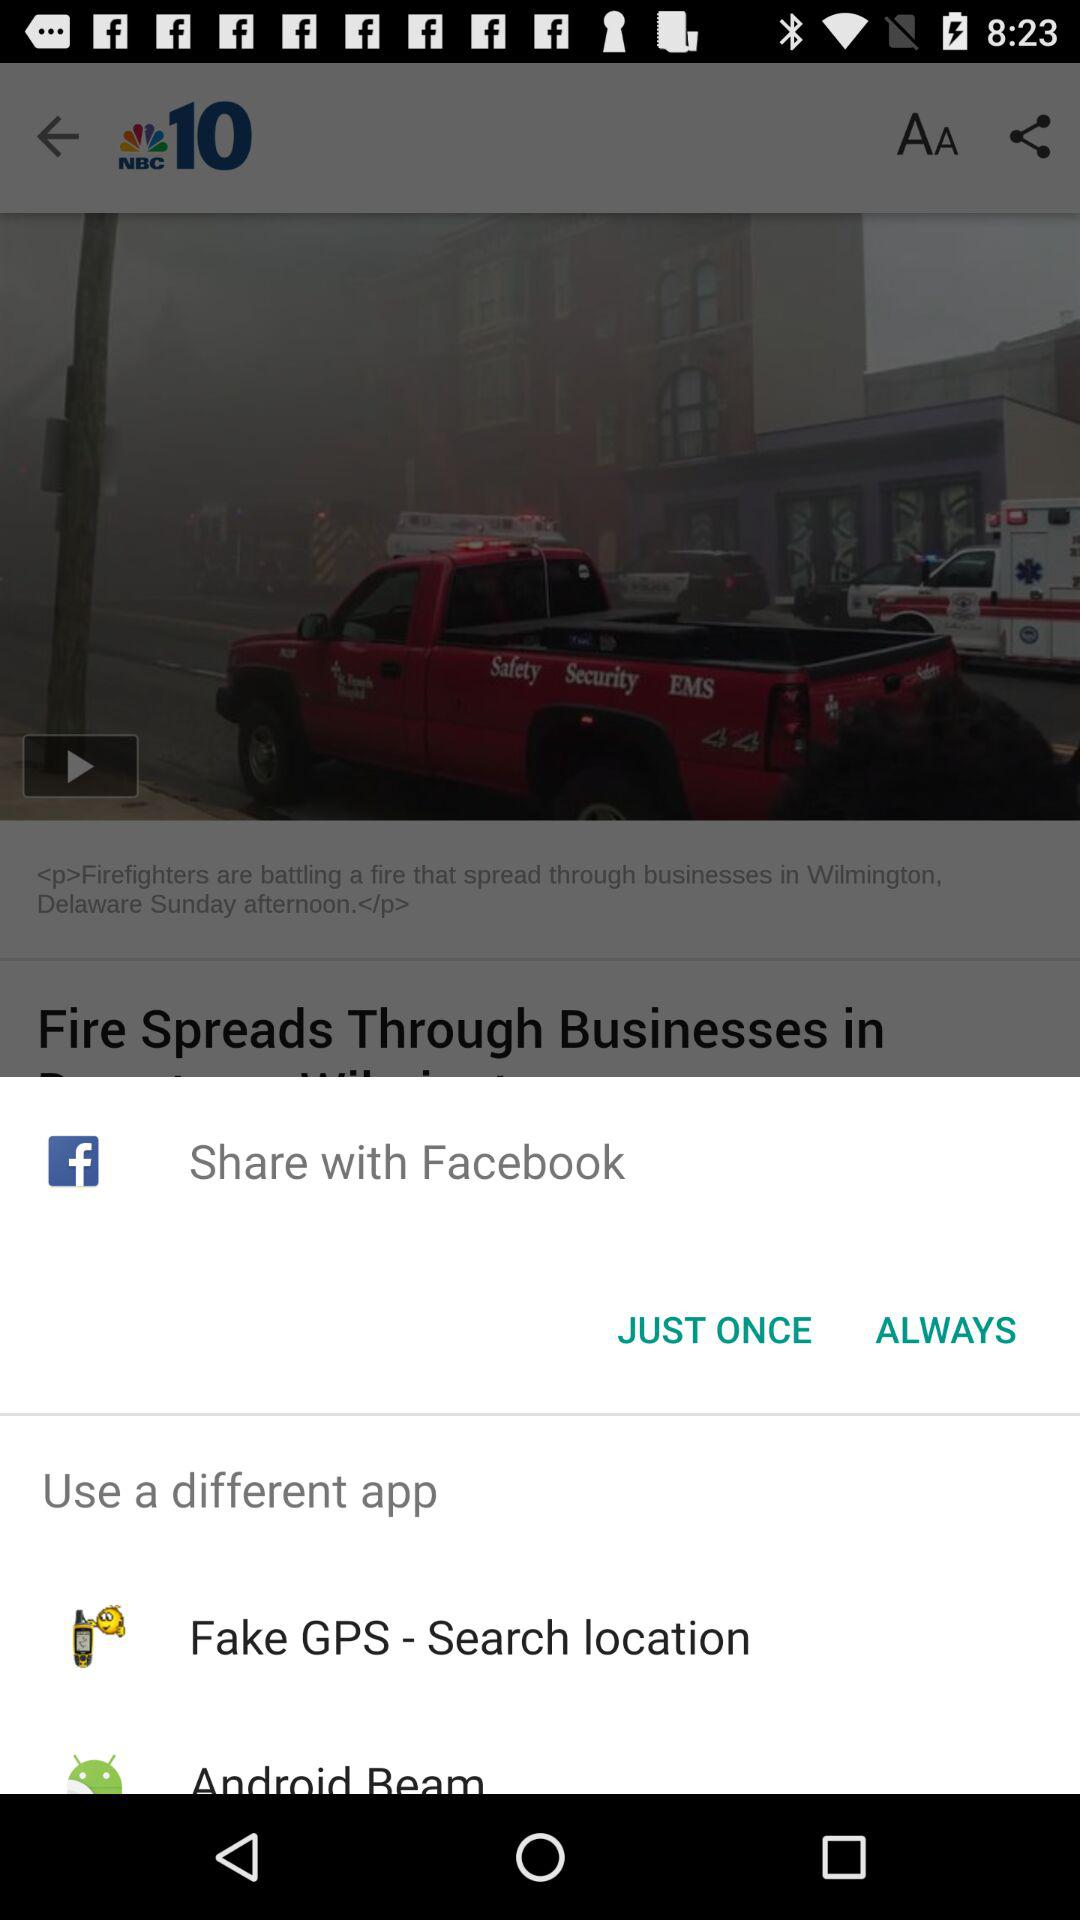Which sharing option is selected?
When the provided information is insufficient, respond with <no answer>. <no answer> 